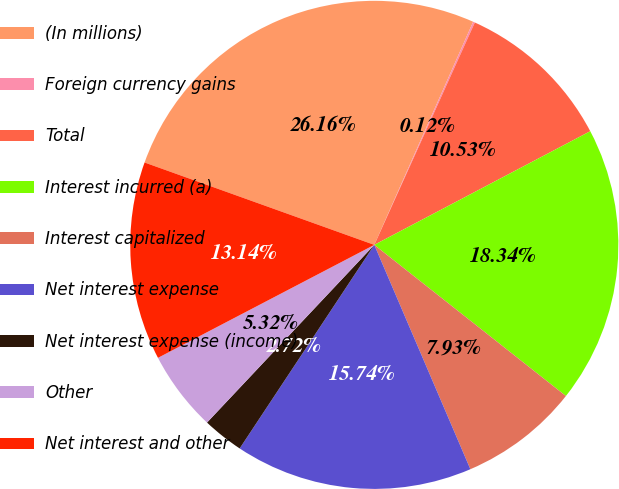<chart> <loc_0><loc_0><loc_500><loc_500><pie_chart><fcel>(In millions)<fcel>Foreign currency gains<fcel>Total<fcel>Interest incurred (a)<fcel>Interest capitalized<fcel>Net interest expense<fcel>Net interest expense (income)<fcel>Other<fcel>Net interest and other<nl><fcel>26.16%<fcel>0.12%<fcel>10.53%<fcel>18.34%<fcel>7.93%<fcel>15.74%<fcel>2.72%<fcel>5.32%<fcel>13.14%<nl></chart> 